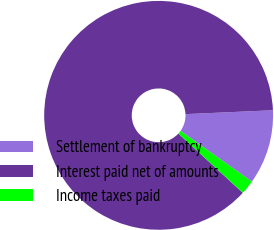Convert chart. <chart><loc_0><loc_0><loc_500><loc_500><pie_chart><fcel>Settlement of bankruptcy<fcel>Interest paid net of amounts<fcel>Income taxes paid<nl><fcel>10.55%<fcel>87.45%<fcel>2.0%<nl></chart> 